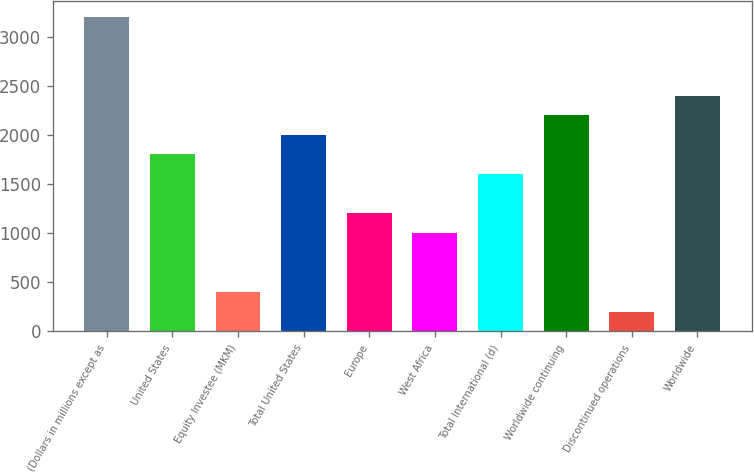Convert chart. <chart><loc_0><loc_0><loc_500><loc_500><bar_chart><fcel>(Dollars in millions except as<fcel>United States<fcel>Equity Investee (MKM)<fcel>Total United States<fcel>Europe<fcel>West Africa<fcel>Total International (d)<fcel>Worldwide continuing<fcel>Discontinued operations<fcel>Worldwide<nl><fcel>3203.24<fcel>1801.84<fcel>400.44<fcel>2002.04<fcel>1201.24<fcel>1001.04<fcel>1601.64<fcel>2202.24<fcel>200.24<fcel>2402.44<nl></chart> 